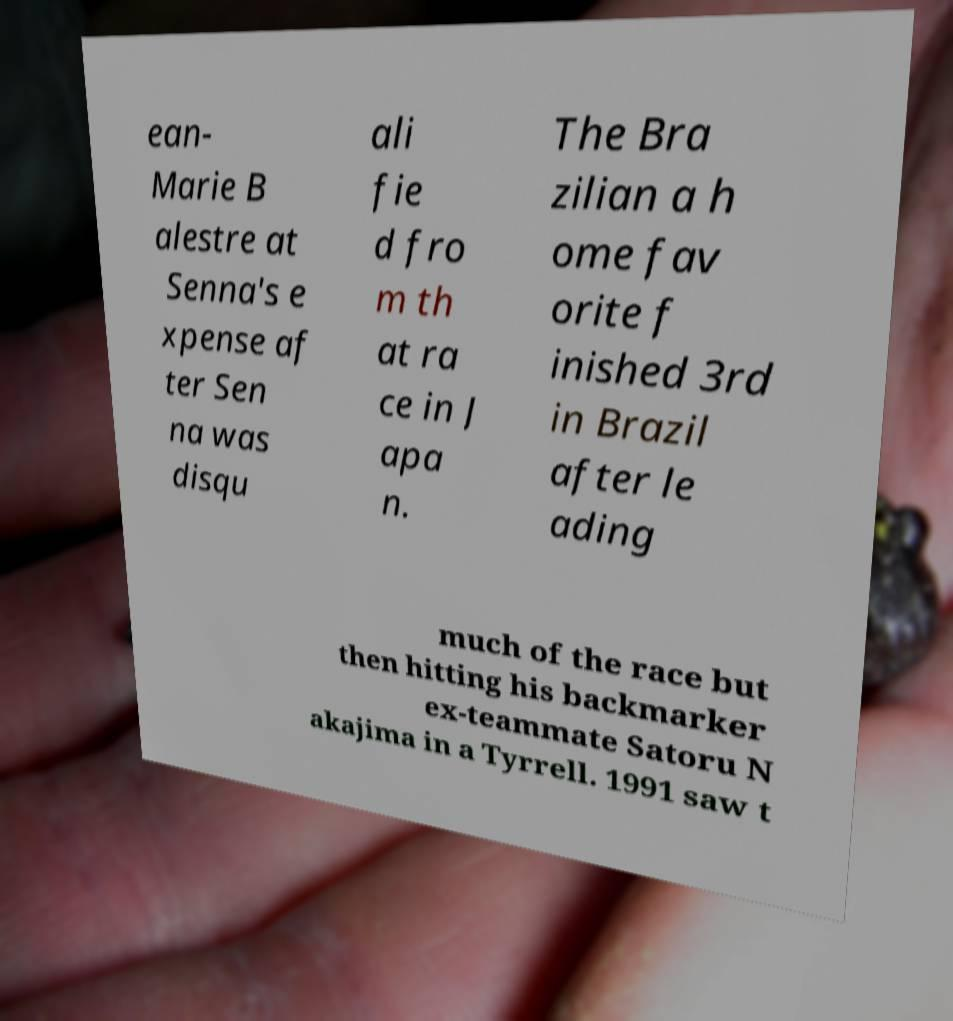Can you accurately transcribe the text from the provided image for me? ean- Marie B alestre at Senna's e xpense af ter Sen na was disqu ali fie d fro m th at ra ce in J apa n. The Bra zilian a h ome fav orite f inished 3rd in Brazil after le ading much of the race but then hitting his backmarker ex-teammate Satoru N akajima in a Tyrrell. 1991 saw t 